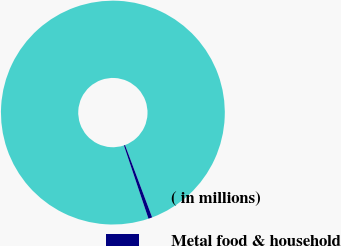Convert chart. <chart><loc_0><loc_0><loc_500><loc_500><pie_chart><fcel>( in millions)<fcel>Metal food & household<nl><fcel>99.44%<fcel>0.56%<nl></chart> 